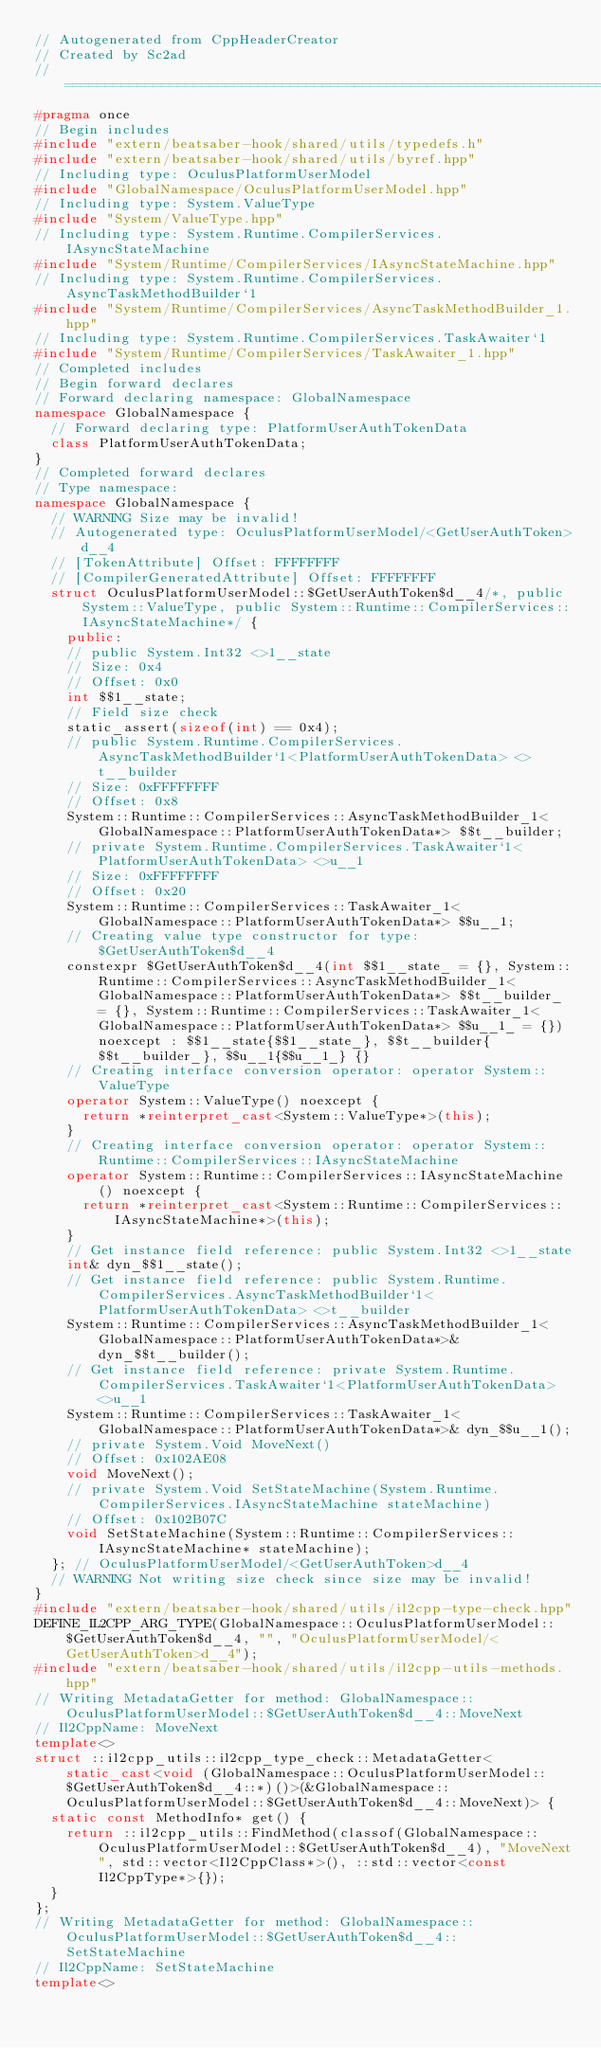<code> <loc_0><loc_0><loc_500><loc_500><_C++_>// Autogenerated from CppHeaderCreator
// Created by Sc2ad
// =========================================================================
#pragma once
// Begin includes
#include "extern/beatsaber-hook/shared/utils/typedefs.h"
#include "extern/beatsaber-hook/shared/utils/byref.hpp"
// Including type: OculusPlatformUserModel
#include "GlobalNamespace/OculusPlatformUserModel.hpp"
// Including type: System.ValueType
#include "System/ValueType.hpp"
// Including type: System.Runtime.CompilerServices.IAsyncStateMachine
#include "System/Runtime/CompilerServices/IAsyncStateMachine.hpp"
// Including type: System.Runtime.CompilerServices.AsyncTaskMethodBuilder`1
#include "System/Runtime/CompilerServices/AsyncTaskMethodBuilder_1.hpp"
// Including type: System.Runtime.CompilerServices.TaskAwaiter`1
#include "System/Runtime/CompilerServices/TaskAwaiter_1.hpp"
// Completed includes
// Begin forward declares
// Forward declaring namespace: GlobalNamespace
namespace GlobalNamespace {
  // Forward declaring type: PlatformUserAuthTokenData
  class PlatformUserAuthTokenData;
}
// Completed forward declares
// Type namespace: 
namespace GlobalNamespace {
  // WARNING Size may be invalid!
  // Autogenerated type: OculusPlatformUserModel/<GetUserAuthToken>d__4
  // [TokenAttribute] Offset: FFFFFFFF
  // [CompilerGeneratedAttribute] Offset: FFFFFFFF
  struct OculusPlatformUserModel::$GetUserAuthToken$d__4/*, public System::ValueType, public System::Runtime::CompilerServices::IAsyncStateMachine*/ {
    public:
    // public System.Int32 <>1__state
    // Size: 0x4
    // Offset: 0x0
    int $$1__state;
    // Field size check
    static_assert(sizeof(int) == 0x4);
    // public System.Runtime.CompilerServices.AsyncTaskMethodBuilder`1<PlatformUserAuthTokenData> <>t__builder
    // Size: 0xFFFFFFFF
    // Offset: 0x8
    System::Runtime::CompilerServices::AsyncTaskMethodBuilder_1<GlobalNamespace::PlatformUserAuthTokenData*> $$t__builder;
    // private System.Runtime.CompilerServices.TaskAwaiter`1<PlatformUserAuthTokenData> <>u__1
    // Size: 0xFFFFFFFF
    // Offset: 0x20
    System::Runtime::CompilerServices::TaskAwaiter_1<GlobalNamespace::PlatformUserAuthTokenData*> $$u__1;
    // Creating value type constructor for type: $GetUserAuthToken$d__4
    constexpr $GetUserAuthToken$d__4(int $$1__state_ = {}, System::Runtime::CompilerServices::AsyncTaskMethodBuilder_1<GlobalNamespace::PlatformUserAuthTokenData*> $$t__builder_ = {}, System::Runtime::CompilerServices::TaskAwaiter_1<GlobalNamespace::PlatformUserAuthTokenData*> $$u__1_ = {}) noexcept : $$1__state{$$1__state_}, $$t__builder{$$t__builder_}, $$u__1{$$u__1_} {}
    // Creating interface conversion operator: operator System::ValueType
    operator System::ValueType() noexcept {
      return *reinterpret_cast<System::ValueType*>(this);
    }
    // Creating interface conversion operator: operator System::Runtime::CompilerServices::IAsyncStateMachine
    operator System::Runtime::CompilerServices::IAsyncStateMachine() noexcept {
      return *reinterpret_cast<System::Runtime::CompilerServices::IAsyncStateMachine*>(this);
    }
    // Get instance field reference: public System.Int32 <>1__state
    int& dyn_$$1__state();
    // Get instance field reference: public System.Runtime.CompilerServices.AsyncTaskMethodBuilder`1<PlatformUserAuthTokenData> <>t__builder
    System::Runtime::CompilerServices::AsyncTaskMethodBuilder_1<GlobalNamespace::PlatformUserAuthTokenData*>& dyn_$$t__builder();
    // Get instance field reference: private System.Runtime.CompilerServices.TaskAwaiter`1<PlatformUserAuthTokenData> <>u__1
    System::Runtime::CompilerServices::TaskAwaiter_1<GlobalNamespace::PlatformUserAuthTokenData*>& dyn_$$u__1();
    // private System.Void MoveNext()
    // Offset: 0x102AE08
    void MoveNext();
    // private System.Void SetStateMachine(System.Runtime.CompilerServices.IAsyncStateMachine stateMachine)
    // Offset: 0x102B07C
    void SetStateMachine(System::Runtime::CompilerServices::IAsyncStateMachine* stateMachine);
  }; // OculusPlatformUserModel/<GetUserAuthToken>d__4
  // WARNING Not writing size check since size may be invalid!
}
#include "extern/beatsaber-hook/shared/utils/il2cpp-type-check.hpp"
DEFINE_IL2CPP_ARG_TYPE(GlobalNamespace::OculusPlatformUserModel::$GetUserAuthToken$d__4, "", "OculusPlatformUserModel/<GetUserAuthToken>d__4");
#include "extern/beatsaber-hook/shared/utils/il2cpp-utils-methods.hpp"
// Writing MetadataGetter for method: GlobalNamespace::OculusPlatformUserModel::$GetUserAuthToken$d__4::MoveNext
// Il2CppName: MoveNext
template<>
struct ::il2cpp_utils::il2cpp_type_check::MetadataGetter<static_cast<void (GlobalNamespace::OculusPlatformUserModel::$GetUserAuthToken$d__4::*)()>(&GlobalNamespace::OculusPlatformUserModel::$GetUserAuthToken$d__4::MoveNext)> {
  static const MethodInfo* get() {
    return ::il2cpp_utils::FindMethod(classof(GlobalNamespace::OculusPlatformUserModel::$GetUserAuthToken$d__4), "MoveNext", std::vector<Il2CppClass*>(), ::std::vector<const Il2CppType*>{});
  }
};
// Writing MetadataGetter for method: GlobalNamespace::OculusPlatformUserModel::$GetUserAuthToken$d__4::SetStateMachine
// Il2CppName: SetStateMachine
template<></code> 